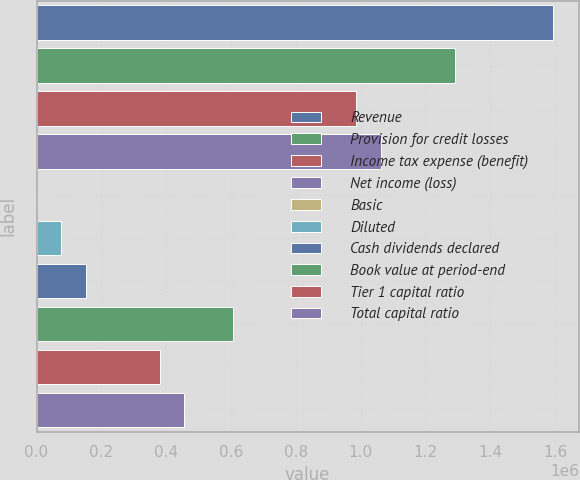Convert chart to OTSL. <chart><loc_0><loc_0><loc_500><loc_500><bar_chart><fcel>Revenue<fcel>Provision for credit losses<fcel>Income tax expense (benefit)<fcel>Net income (loss)<fcel>Basic<fcel>Diluted<fcel>Cash dividends declared<fcel>Book value at period-end<fcel>Tier 1 capital ratio<fcel>Total capital ratio<nl><fcel>1.59348e+06<fcel>1.28996e+06<fcel>986440<fcel>1.06232e+06<fcel>0.2<fcel>75880.2<fcel>151760<fcel>607040<fcel>379400<fcel>455280<nl></chart> 